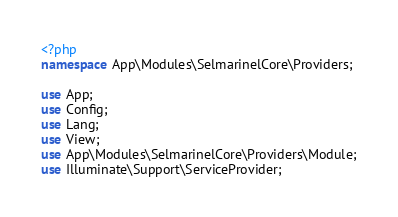Convert code to text. <code><loc_0><loc_0><loc_500><loc_500><_PHP_><?php
namespace App\Modules\SelmarinelCore\Providers;

use App;
use Config;
use Lang;
use View;
use App\Modules\SelmarinelCore\Providers\Module;
use Illuminate\Support\ServiceProvider;
</code> 